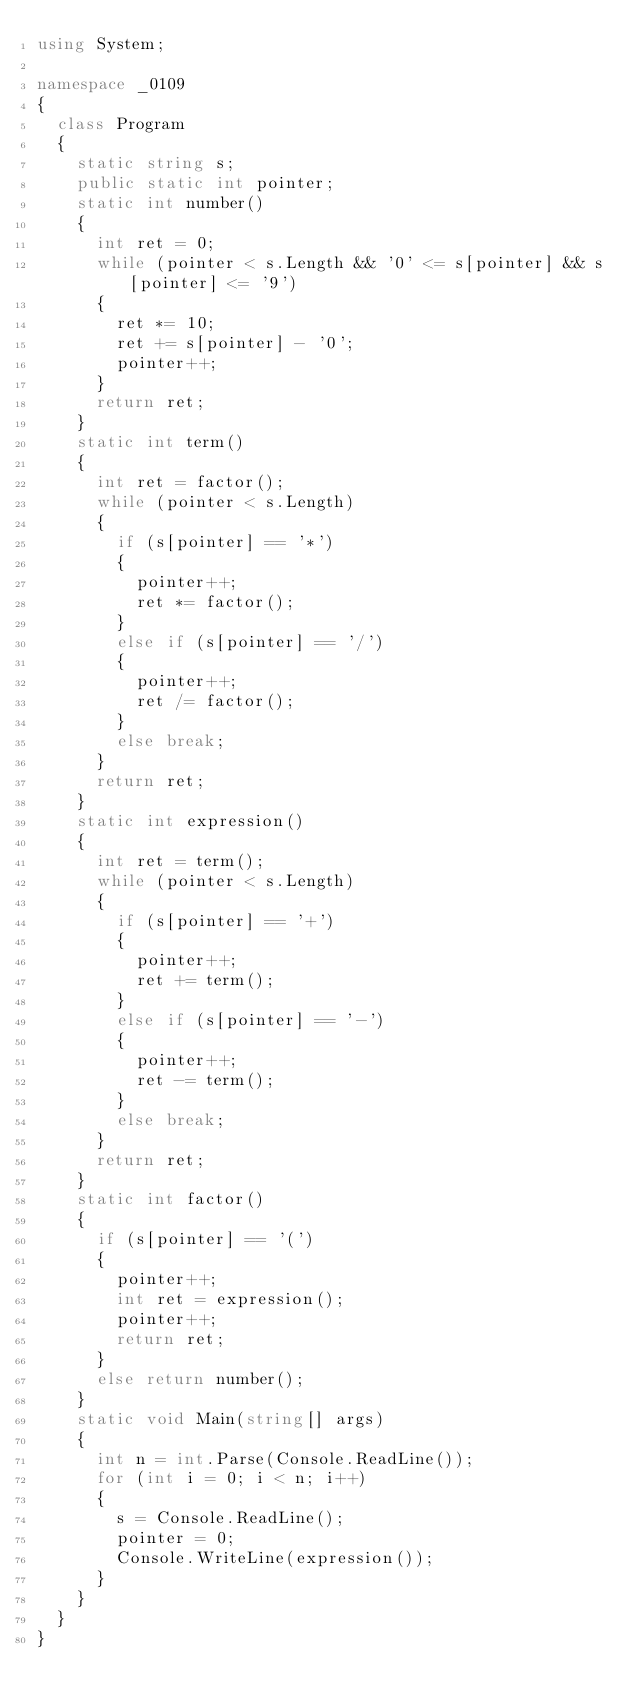Convert code to text. <code><loc_0><loc_0><loc_500><loc_500><_C#_>using System;

namespace _0109
{
	class Program
	{
		static string s;
		public static int pointer;
		static int number()
		{
			int ret = 0;
			while (pointer < s.Length && '0' <= s[pointer] && s[pointer] <= '9')
			{
				ret *= 10;
				ret += s[pointer] - '0';
				pointer++;
			}
			return ret;
		}
		static int term()
		{
			int ret = factor();
			while (pointer < s.Length)
			{
				if (s[pointer] == '*')
				{
					pointer++;
					ret *= factor();
				}
				else if (s[pointer] == '/')
				{
					pointer++;
					ret /= factor();
				}
				else break;
			}
			return ret;
		}
		static int expression()
		{
			int ret = term();
			while (pointer < s.Length)
			{
				if (s[pointer] == '+')
				{
					pointer++;
					ret += term();
				}
				else if (s[pointer] == '-')
				{
					pointer++;
					ret -= term();
				}
				else break;
			}
			return ret;
		}
		static int factor()
		{
			if (s[pointer] == '(')
			{
				pointer++;
				int ret = expression();
				pointer++;
				return ret;
			}
			else return number();
		}
		static void Main(string[] args)
		{
			int n = int.Parse(Console.ReadLine());
			for (int i = 0; i < n; i++)
			{
				s = Console.ReadLine();
				pointer = 0;
				Console.WriteLine(expression());
			}
		}
	}
}
</code> 